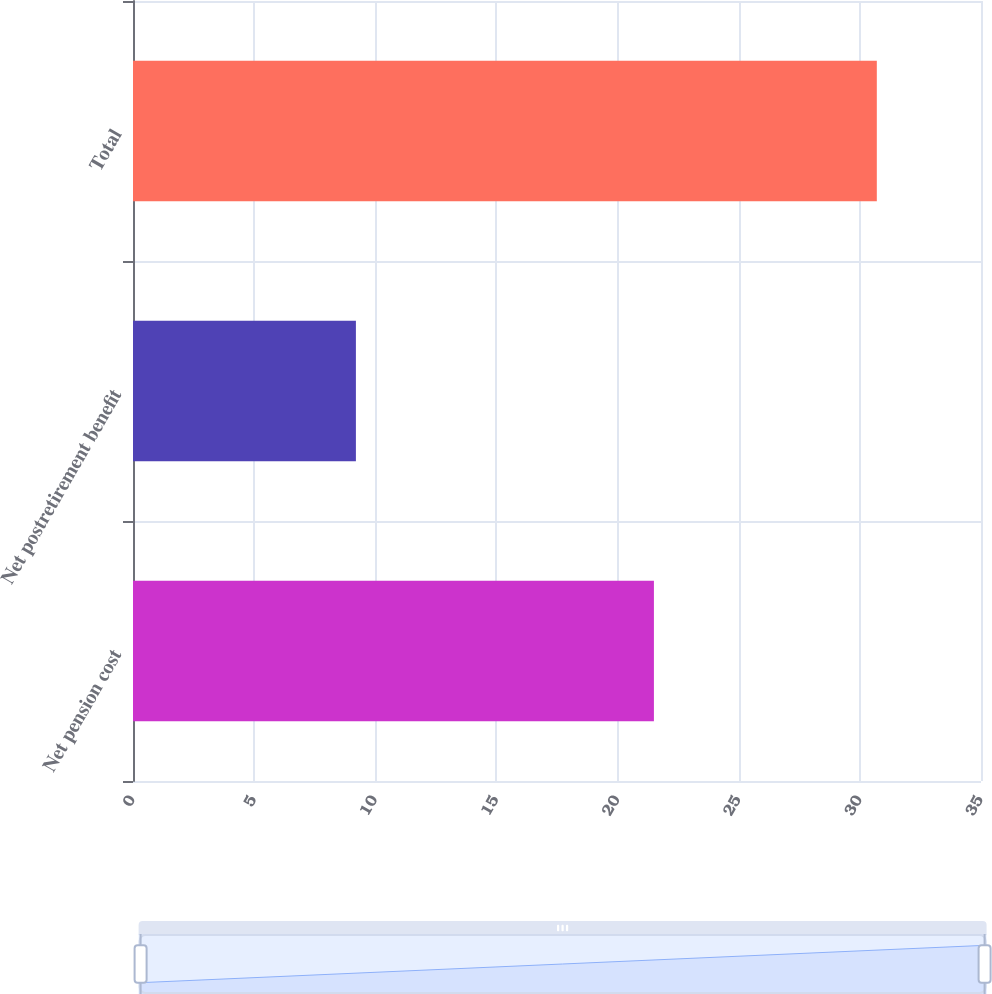<chart> <loc_0><loc_0><loc_500><loc_500><bar_chart><fcel>Net pension cost<fcel>Net postretirement benefit<fcel>Total<nl><fcel>21.5<fcel>9.2<fcel>30.7<nl></chart> 